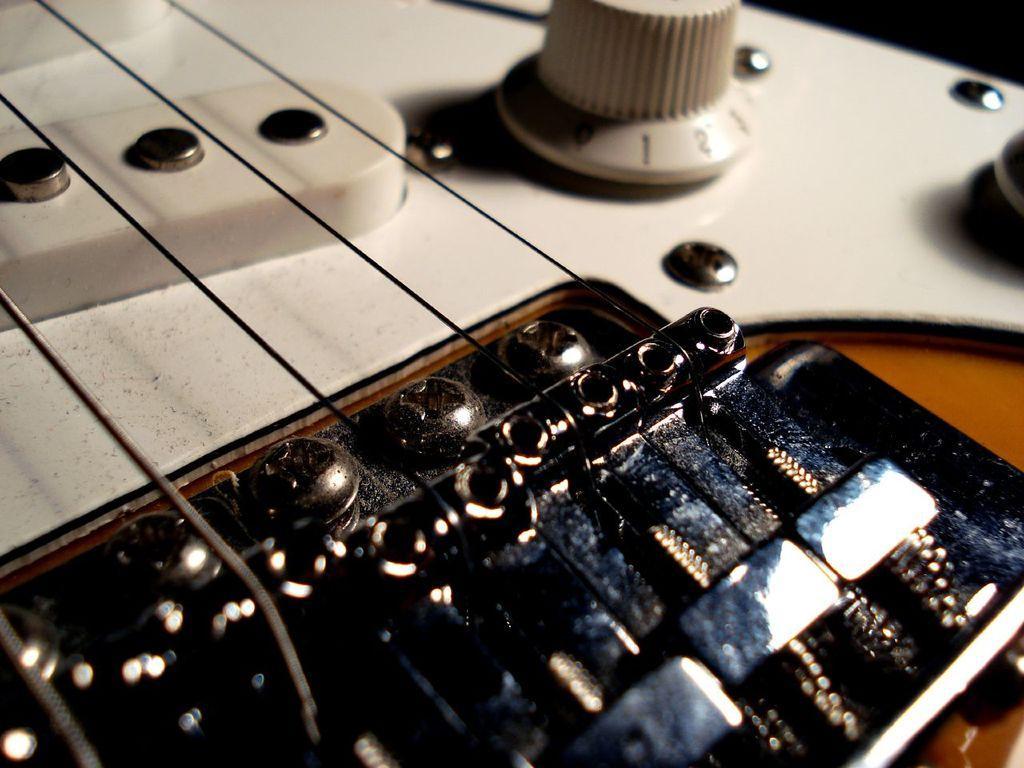Please provide a concise description of this image. In this image there is a guitar. This is a regulator. These are bolts. 